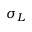<formula> <loc_0><loc_0><loc_500><loc_500>\sigma _ { L }</formula> 